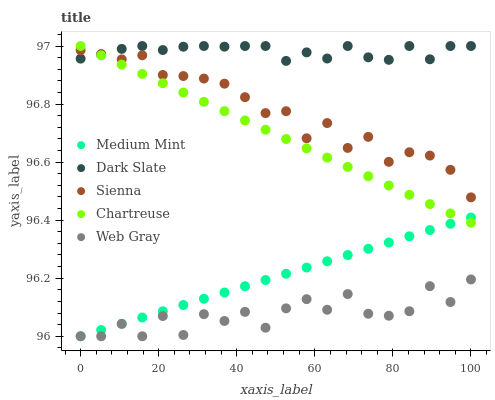Does Web Gray have the minimum area under the curve?
Answer yes or no. Yes. Does Dark Slate have the maximum area under the curve?
Answer yes or no. Yes. Does Chartreuse have the minimum area under the curve?
Answer yes or no. No. Does Chartreuse have the maximum area under the curve?
Answer yes or no. No. Is Medium Mint the smoothest?
Answer yes or no. Yes. Is Web Gray the roughest?
Answer yes or no. Yes. Is Dark Slate the smoothest?
Answer yes or no. No. Is Dark Slate the roughest?
Answer yes or no. No. Does Medium Mint have the lowest value?
Answer yes or no. Yes. Does Chartreuse have the lowest value?
Answer yes or no. No. Does Chartreuse have the highest value?
Answer yes or no. Yes. Does Web Gray have the highest value?
Answer yes or no. No. Is Medium Mint less than Dark Slate?
Answer yes or no. Yes. Is Sienna greater than Web Gray?
Answer yes or no. Yes. Does Dark Slate intersect Chartreuse?
Answer yes or no. Yes. Is Dark Slate less than Chartreuse?
Answer yes or no. No. Is Dark Slate greater than Chartreuse?
Answer yes or no. No. Does Medium Mint intersect Dark Slate?
Answer yes or no. No. 